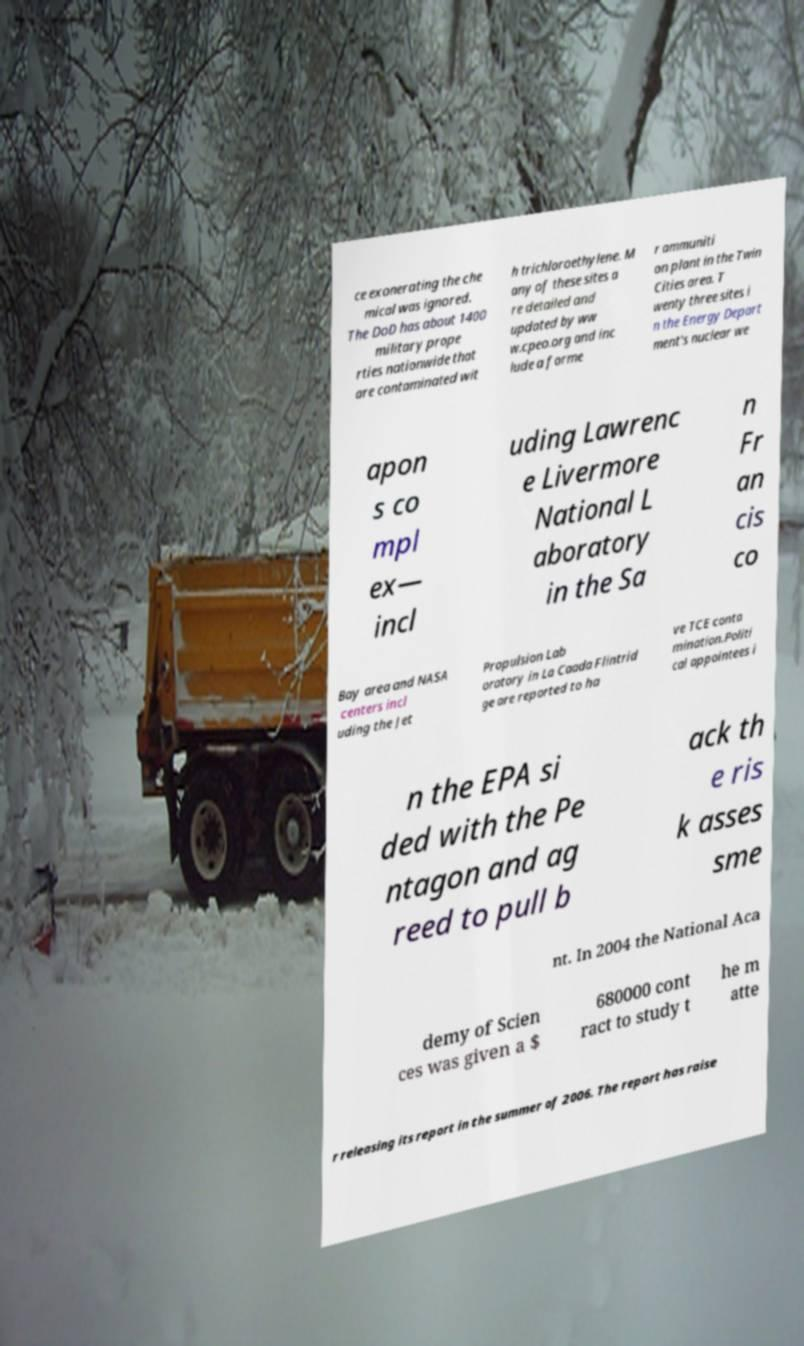What messages or text are displayed in this image? I need them in a readable, typed format. ce exonerating the che mical was ignored. The DoD has about 1400 military prope rties nationwide that are contaminated wit h trichloroethylene. M any of these sites a re detailed and updated by ww w.cpeo.org and inc lude a forme r ammuniti on plant in the Twin Cities area. T wenty three sites i n the Energy Depart ment's nuclear we apon s co mpl ex— incl uding Lawrenc e Livermore National L aboratory in the Sa n Fr an cis co Bay area and NASA centers incl uding the Jet Propulsion Lab oratory in La Caada Flintrid ge are reported to ha ve TCE conta mination.Politi cal appointees i n the EPA si ded with the Pe ntagon and ag reed to pull b ack th e ris k asses sme nt. In 2004 the National Aca demy of Scien ces was given a $ 680000 cont ract to study t he m atte r releasing its report in the summer of 2006. The report has raise 